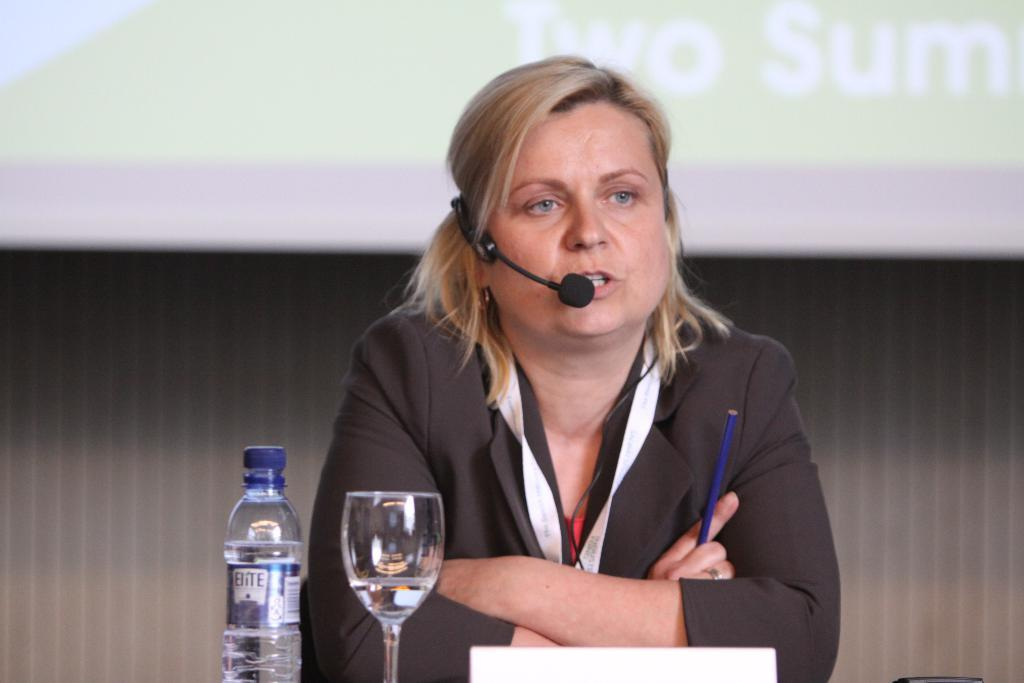Who is the main subject in the image? There is a woman in the center of the image. What is the woman doing in the image? The woman is talking. What is on the table in front of the woman? There is a glass and a bottle on the table. What is the woman holding in her hand? The woman is holding a pencil. What can be seen in the background of the image? There is a screen visible in the background. What type of pickle is on the table in the image? There is no pickle present on the table in the image. How does the rock contribute to the conversation in the image? There is no rock present in the image, so it cannot contribute to the conversation. 